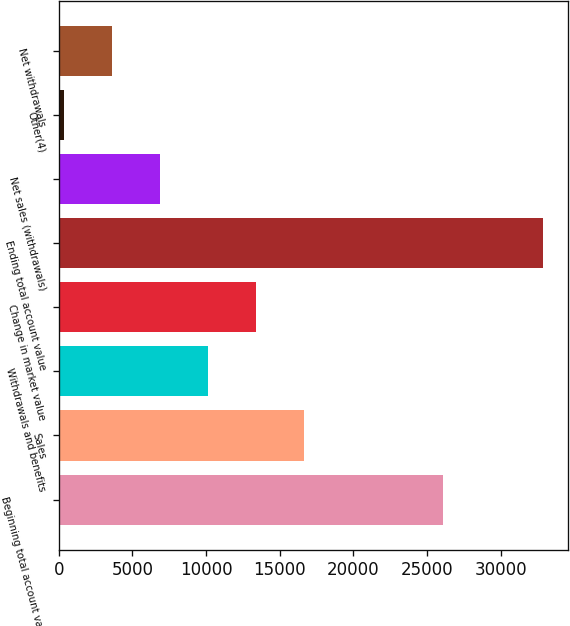<chart> <loc_0><loc_0><loc_500><loc_500><bar_chart><fcel>Beginning total account value<fcel>Sales<fcel>Withdrawals and benefits<fcel>Change in market value<fcel>Ending total account value<fcel>Net sales (withdrawals)<fcel>Other(4)<fcel>Net withdrawals<nl><fcel>26107<fcel>16642<fcel>10134.4<fcel>13388.2<fcel>32911<fcel>6880.6<fcel>373<fcel>3626.8<nl></chart> 